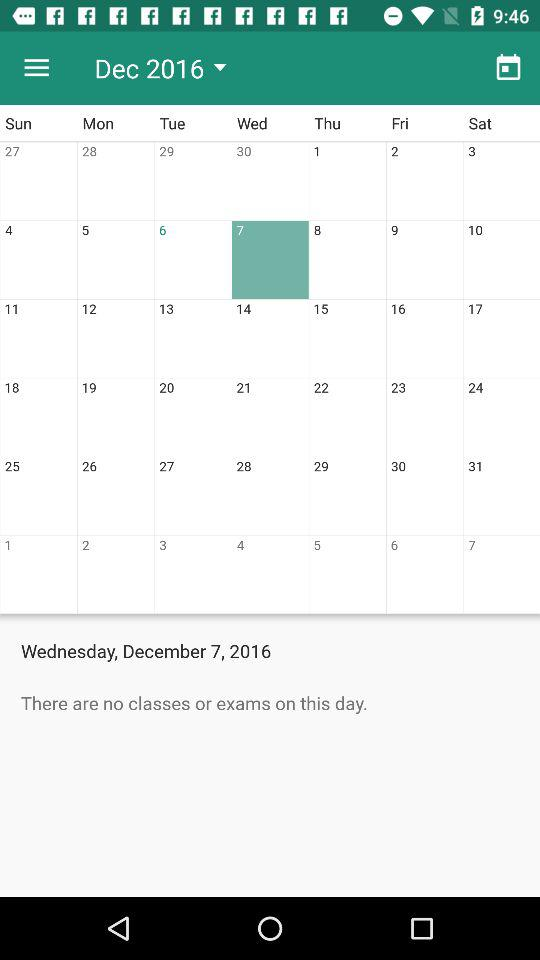Which year is selected? The selected year is 2016. 